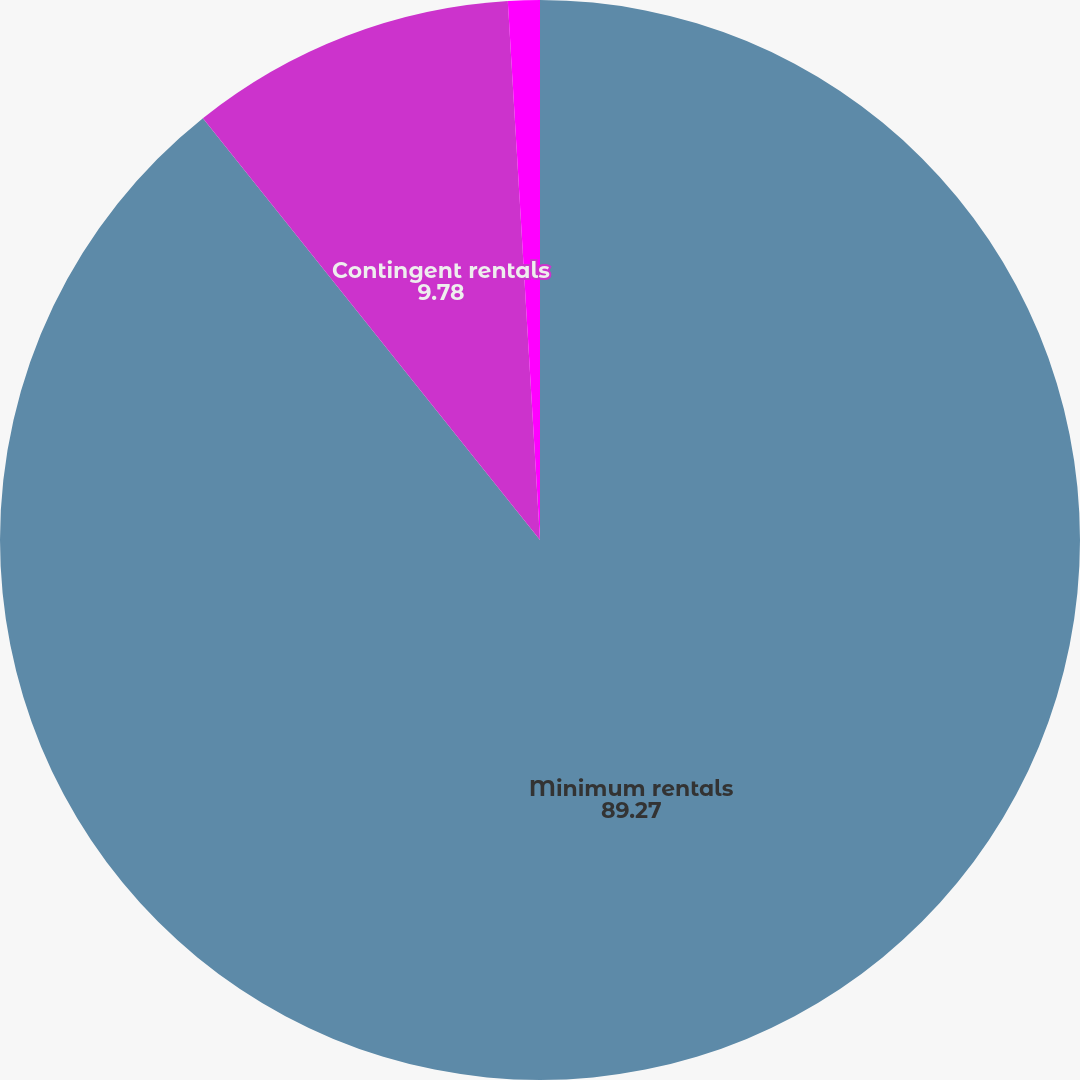<chart> <loc_0><loc_0><loc_500><loc_500><pie_chart><fcel>Minimum rentals<fcel>Contingent rentals<fcel>Sublease rental income<nl><fcel>89.27%<fcel>9.78%<fcel>0.95%<nl></chart> 